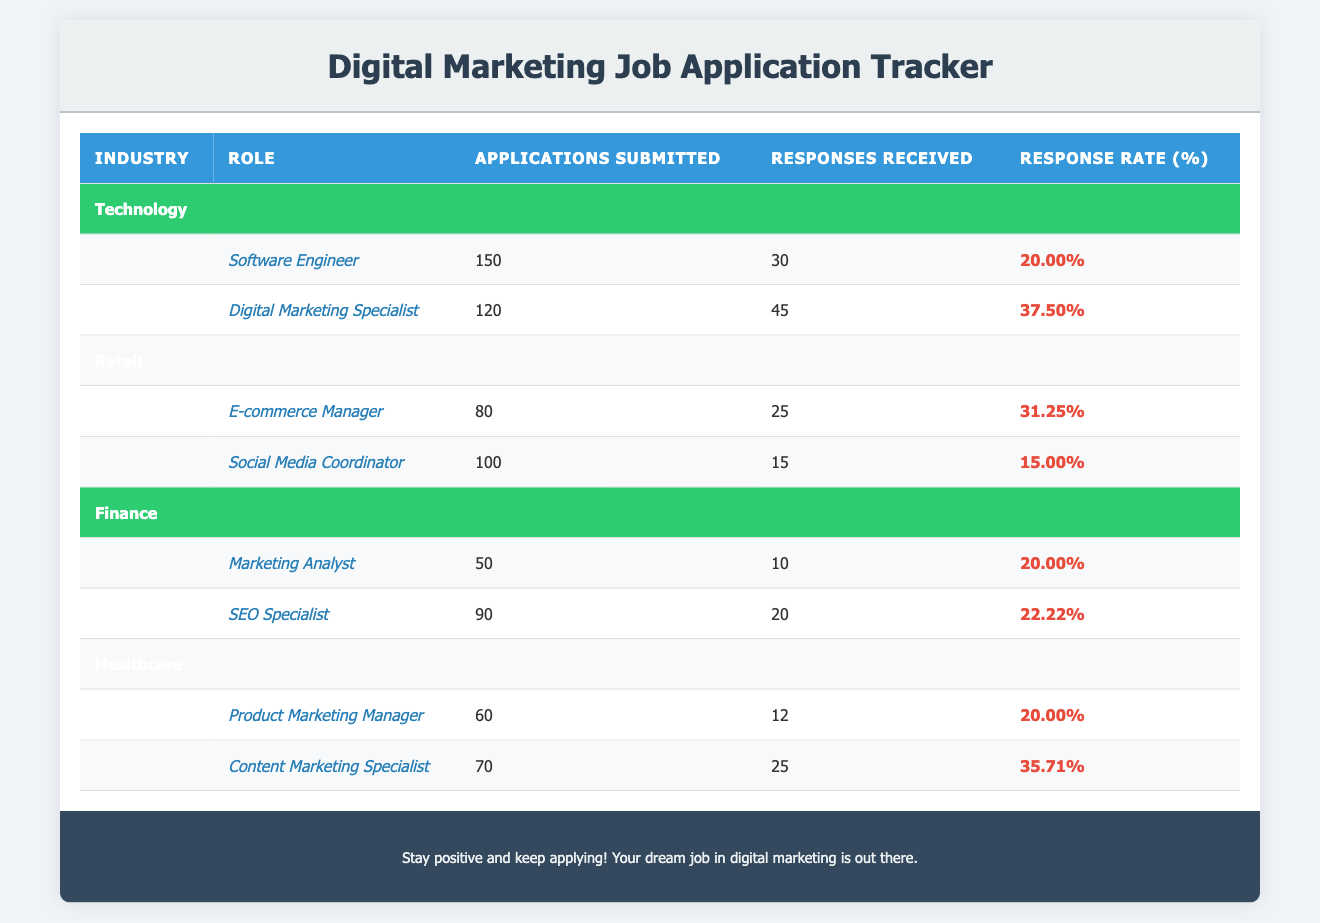What is the response rate for the Digital Marketing Specialist role? The response rate for the Digital Marketing Specialist role is listed in the table under the Technology industry. For this role, the "Response Rate (%)" value is 37.5.
Answer: 37.5 Which industry has the highest average response rate? To find the industry with the highest average response rate, we will calculate the average for each industry: Technology: (20 + 37.5) / 2 = 28.75; Retail: (31.25 + 15) / 2 = 23.125; Finance: (20 + 22.22) / 2 = 21.11; Healthcare: (20 + 35.71) / 2 = 27.85. The highest average is in Technology with 28.75.
Answer: Technology Did the E-commerce Manager receive more responses than the Digital Marketing Specialist? For the E-commerce Manager, the responses received are 25, and for the Digital Marketing Specialist, the responses received are 45. Comparing these numbers, 25 is less than 45.
Answer: No What is the total number of applications submitted in the Retail industry? The total applications submitted in Retail is the sum of E-commerce Manager and Social Media Coordinator applications: 80 + 100 = 180.
Answer: 180 Is the response rate for the SEO Specialist higher than for the Product Marketing Manager? The response rate for the SEO Specialist is 22.22%, and for the Product Marketing Manager, it is 20%. Comparing these values, 22.22% is greater than 20%.
Answer: Yes If you wanted to calculate the overall response rate across all job roles, what formula would you use? To calculate the overall response rate, you would sum all the responses received and divide that by the total applications submitted. The formula would be: (30 + 45 + 25 + 15 + 10 + 20 + 12 + 25) / (150 + 120 + 80 + 100 + 50 + 90 + 60 + 70).
Answer: Sum of responses / Sum of applications What is the lowest response rate among the roles listed? To determine the lowest response rate, we compare all the response rates mentioned: 20, 37.5, 31.25, 15, 20, 22.22, 20, 35.71. The lowest value from these is 15.
Answer: 15 Which role in Finance received the most applications submitted? In the Finance industry, the Marketing Analyst had 50 applications, while the SEO Specialist had 90 applications. Therefore, the SEO Specialist received the most applications.
Answer: SEO Specialist What is the total number of applications submitted for all roles in the Healthcare industry? For the Healthcare industry, we sum the applications for both roles: Product Marketing Manager (60) and Content Marketing Specialist (70): 60 + 70 = 130.
Answer: 130 